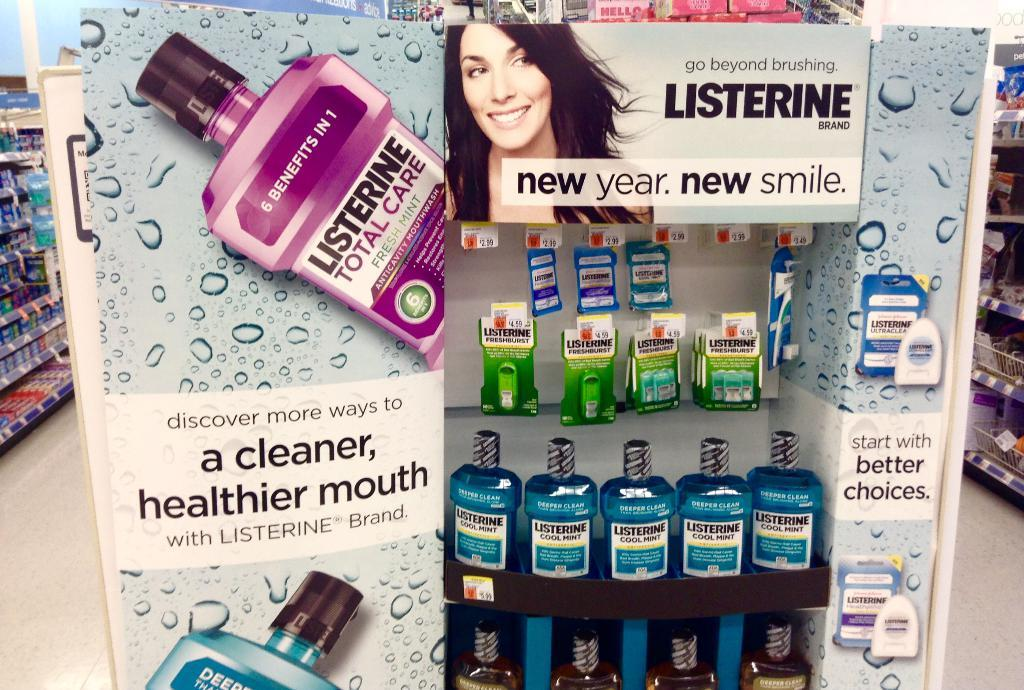<image>
Write a terse but informative summary of the picture. A row of Listerine bottles on a display shelf in a store. 